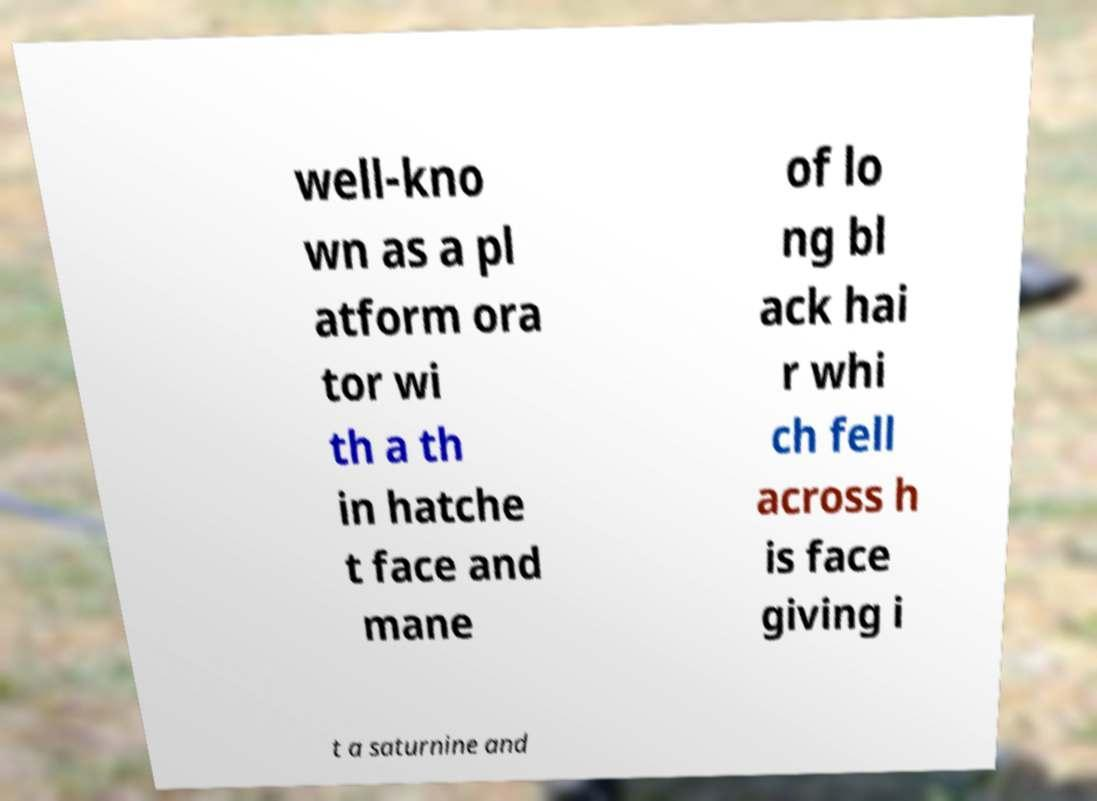What messages or text are displayed in this image? I need them in a readable, typed format. well-kno wn as a pl atform ora tor wi th a th in hatche t face and mane of lo ng bl ack hai r whi ch fell across h is face giving i t a saturnine and 